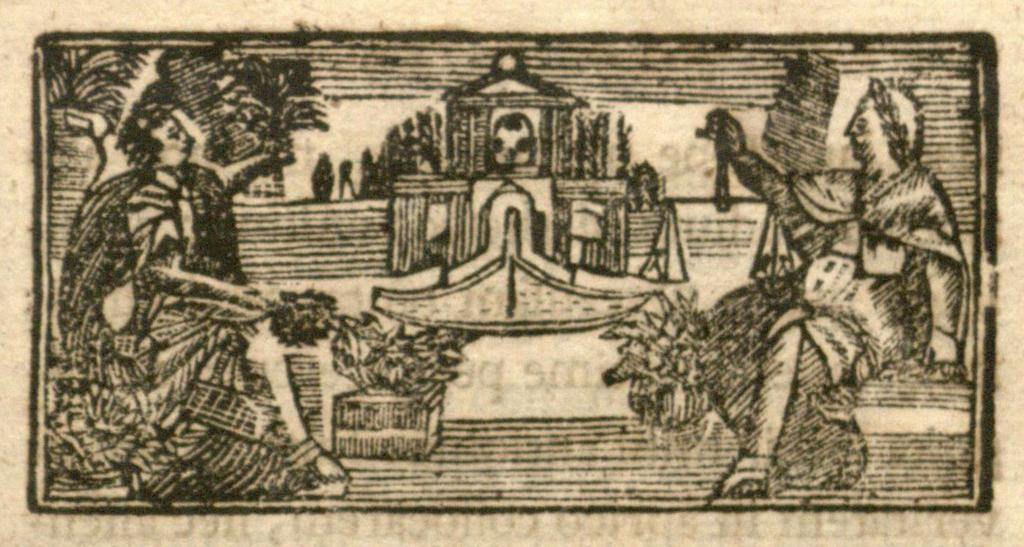What is the main subject of the image? The main subject of the image is a drawing. Can you describe the people in the image? There is a person on the left side of the image and another person on the right side of the image. What type of glass is being used by the actor in the image? There is no actor or glass present in the image; it features a drawing with two people. How many balls are visible in the image? There are no balls visible in the image; it features a drawing with two people. 